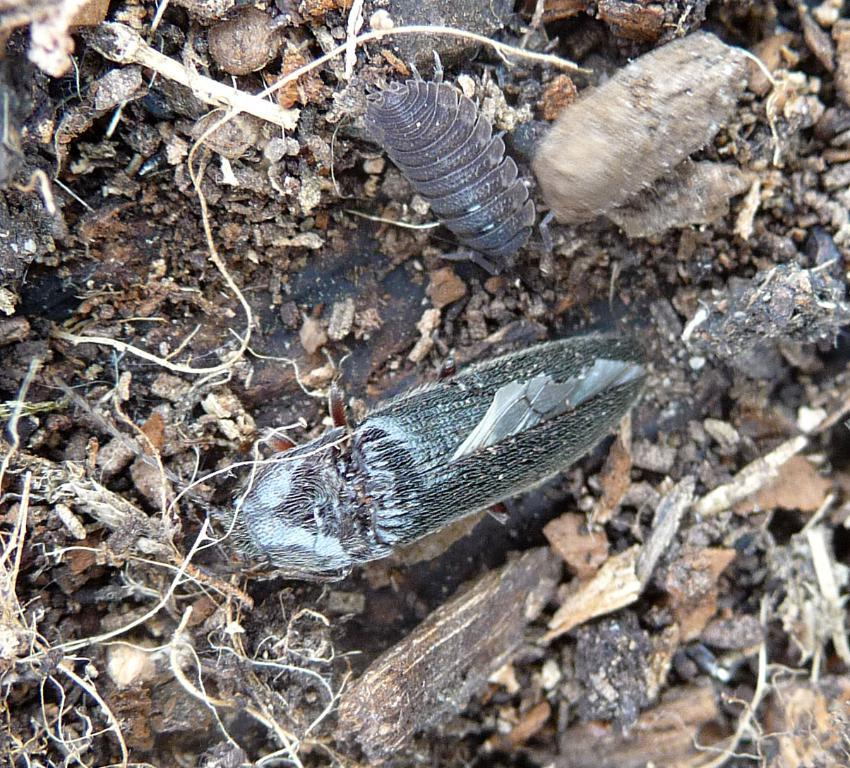What type of creatures can be seen on the ground in the image? There are insects on the ground in the image. What type of curtain can be seen hanging from the insects in the image? There is no curtain present in the image, as it features insects on the ground. What type of rice can be seen being prepared by the insects in the image? There is no rice present in the image, and the insects are not shown preparing any food. 